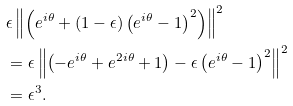Convert formula to latex. <formula><loc_0><loc_0><loc_500><loc_500>& \epsilon \left \| \left ( e ^ { i \theta } + \left ( 1 - \epsilon \right ) \left ( e ^ { i \theta } - 1 \right ) ^ { 2 } \right ) \right \| ^ { 2 } \\ & = \epsilon \left \| \left ( - e ^ { i \theta } + e ^ { 2 i \theta } + 1 \right ) - \epsilon \left ( e ^ { i \theta } - 1 \right ) ^ { 2 } \right \| ^ { 2 } \\ & = \epsilon ^ { 3 } .</formula> 